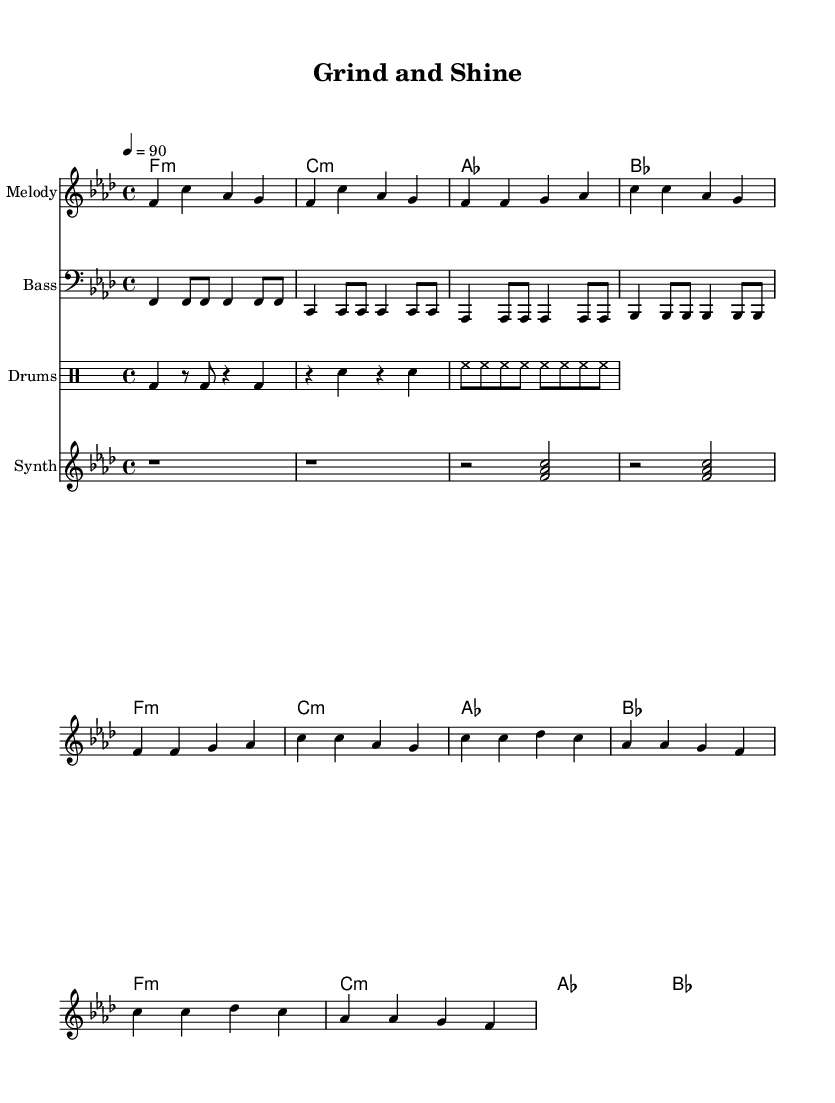What is the key signature of this music? The key signature is indicated at the beginning of the staff and specifies F minor. It indicates the presence of flats that alter specific notes.
Answer: F minor What is the time signature of this music? The time signature is located at the beginning of the staff, showing how many beats are in a measure. In this case, it is 4/4, meaning there are four beats per measure.
Answer: 4/4 What is the tempo marking in this piece? The tempo marking indicates the speed of the music, found at the start of the score. It shows a beat of 90 beats per minute.
Answer: 90 How many sections does this piece have? By analyzing the structure presented in the music, there is a clear division into an intro, verse, and chorus, indicating at least three distinct sections.
Answer: Three What is the primary lyrical theme of the song? The lyrics reflect a motivational theme centered on hard work and discipline as seen in the phrases that emphasize the ideas of grinding and shining.
Answer: Motivation Which instrument primarily carries the melody in this music? The melody is notated on the treble staff, which is typically played by instruments like the piano, flute, or violins. In this case, it is identified simply as "Melody."
Answer: Melody What is the mood created by the harmonic progressions in this piece? The use of minor chords throughout the piece contributes to a determined and serious mood, reflecting the song's theme of discipline and hard work. The harmonic context supports the motivational content.
Answer: Determined 